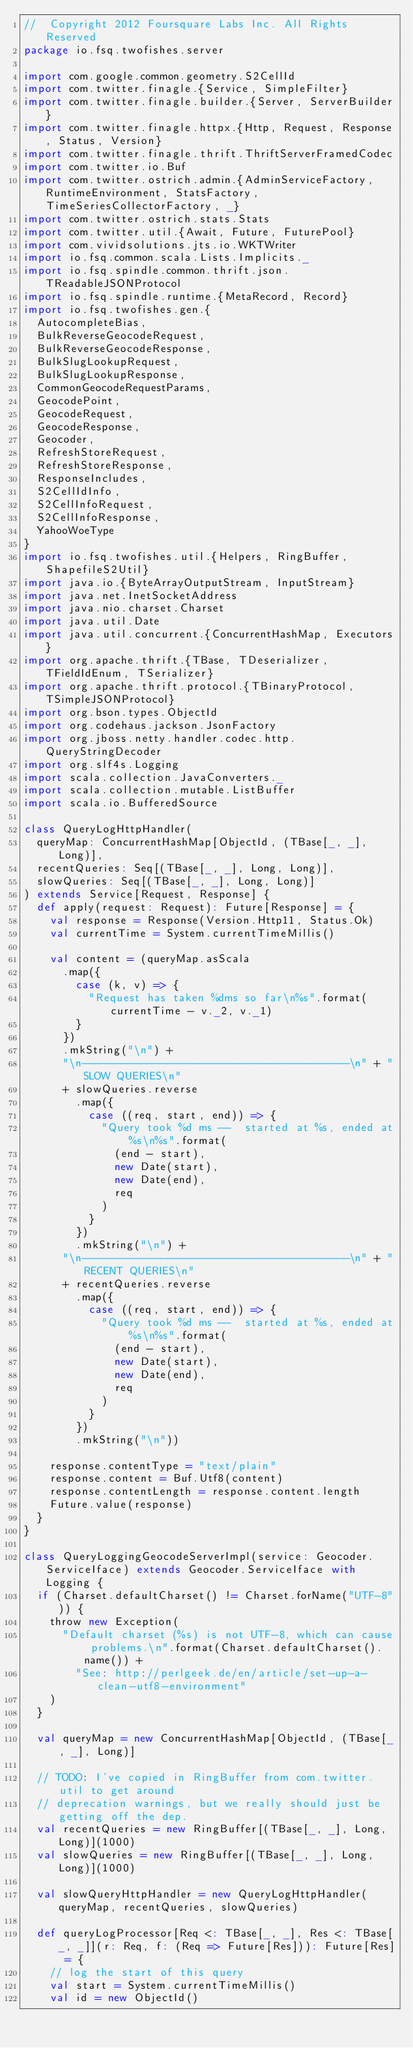Convert code to text. <code><loc_0><loc_0><loc_500><loc_500><_Scala_>//  Copyright 2012 Foursquare Labs Inc. All Rights Reserved
package io.fsq.twofishes.server

import com.google.common.geometry.S2CellId
import com.twitter.finagle.{Service, SimpleFilter}
import com.twitter.finagle.builder.{Server, ServerBuilder}
import com.twitter.finagle.httpx.{Http, Request, Response, Status, Version}
import com.twitter.finagle.thrift.ThriftServerFramedCodec
import com.twitter.io.Buf
import com.twitter.ostrich.admin.{AdminServiceFactory, RuntimeEnvironment, StatsFactory, TimeSeriesCollectorFactory, _}
import com.twitter.ostrich.stats.Stats
import com.twitter.util.{Await, Future, FuturePool}
import com.vividsolutions.jts.io.WKTWriter
import io.fsq.common.scala.Lists.Implicits._
import io.fsq.spindle.common.thrift.json.TReadableJSONProtocol
import io.fsq.spindle.runtime.{MetaRecord, Record}
import io.fsq.twofishes.gen.{
  AutocompleteBias,
  BulkReverseGeocodeRequest,
  BulkReverseGeocodeResponse,
  BulkSlugLookupRequest,
  BulkSlugLookupResponse,
  CommonGeocodeRequestParams,
  GeocodePoint,
  GeocodeRequest,
  GeocodeResponse,
  Geocoder,
  RefreshStoreRequest,
  RefreshStoreResponse,
  ResponseIncludes,
  S2CellIdInfo,
  S2CellInfoRequest,
  S2CellInfoResponse,
  YahooWoeType
}
import io.fsq.twofishes.util.{Helpers, RingBuffer, ShapefileS2Util}
import java.io.{ByteArrayOutputStream, InputStream}
import java.net.InetSocketAddress
import java.nio.charset.Charset
import java.util.Date
import java.util.concurrent.{ConcurrentHashMap, Executors}
import org.apache.thrift.{TBase, TDeserializer, TFieldIdEnum, TSerializer}
import org.apache.thrift.protocol.{TBinaryProtocol, TSimpleJSONProtocol}
import org.bson.types.ObjectId
import org.codehaus.jackson.JsonFactory
import org.jboss.netty.handler.codec.http.QueryStringDecoder
import org.slf4s.Logging
import scala.collection.JavaConverters._
import scala.collection.mutable.ListBuffer
import scala.io.BufferedSource

class QueryLogHttpHandler(
  queryMap: ConcurrentHashMap[ObjectId, (TBase[_, _], Long)],
  recentQueries: Seq[(TBase[_, _], Long, Long)],
  slowQueries: Seq[(TBase[_, _], Long, Long)]
) extends Service[Request, Response] {
  def apply(request: Request): Future[Response] = {
    val response = Response(Version.Http11, Status.Ok)
    val currentTime = System.currentTimeMillis()

    val content = (queryMap.asScala
      .map({
        case (k, v) => {
          "Request has taken %dms so far\n%s".format(currentTime - v._2, v._1)
        }
      })
      .mkString("\n") +
      "\n-----------------------------------------\n" + "SLOW QUERIES\n"
      + slowQueries.reverse
        .map({
          case ((req, start, end)) => {
            "Query took %d ms --  started at %s, ended at %s\n%s".format(
              (end - start),
              new Date(start),
              new Date(end),
              req
            )
          }
        })
        .mkString("\n") +
      "\n-----------------------------------------\n" + "RECENT QUERIES\n"
      + recentQueries.reverse
        .map({
          case ((req, start, end)) => {
            "Query took %d ms --  started at %s, ended at %s\n%s".format(
              (end - start),
              new Date(start),
              new Date(end),
              req
            )
          }
        })
        .mkString("\n"))

    response.contentType = "text/plain"
    response.content = Buf.Utf8(content)
    response.contentLength = response.content.length
    Future.value(response)
  }
}

class QueryLoggingGeocodeServerImpl(service: Geocoder.ServiceIface) extends Geocoder.ServiceIface with Logging {
  if (Charset.defaultCharset() != Charset.forName("UTF-8")) {
    throw new Exception(
      "Default charset (%s) is not UTF-8, which can cause problems.\n".format(Charset.defaultCharset().name()) +
        "See: http://perlgeek.de/en/article/set-up-a-clean-utf8-environment"
    )
  }

  val queryMap = new ConcurrentHashMap[ObjectId, (TBase[_, _], Long)]

  // TODO: I've copied in RingBuffer from com.twitter.util to get around
  // deprecation warnings, but we really should just be getting off the dep.
  val recentQueries = new RingBuffer[(TBase[_, _], Long, Long)](1000)
  val slowQueries = new RingBuffer[(TBase[_, _], Long, Long)](1000)

  val slowQueryHttpHandler = new QueryLogHttpHandler(queryMap, recentQueries, slowQueries)

  def queryLogProcessor[Req <: TBase[_, _], Res <: TBase[_, _]](r: Req, f: (Req => Future[Res])): Future[Res] = {
    // log the start of this query
    val start = System.currentTimeMillis()
    val id = new ObjectId()</code> 